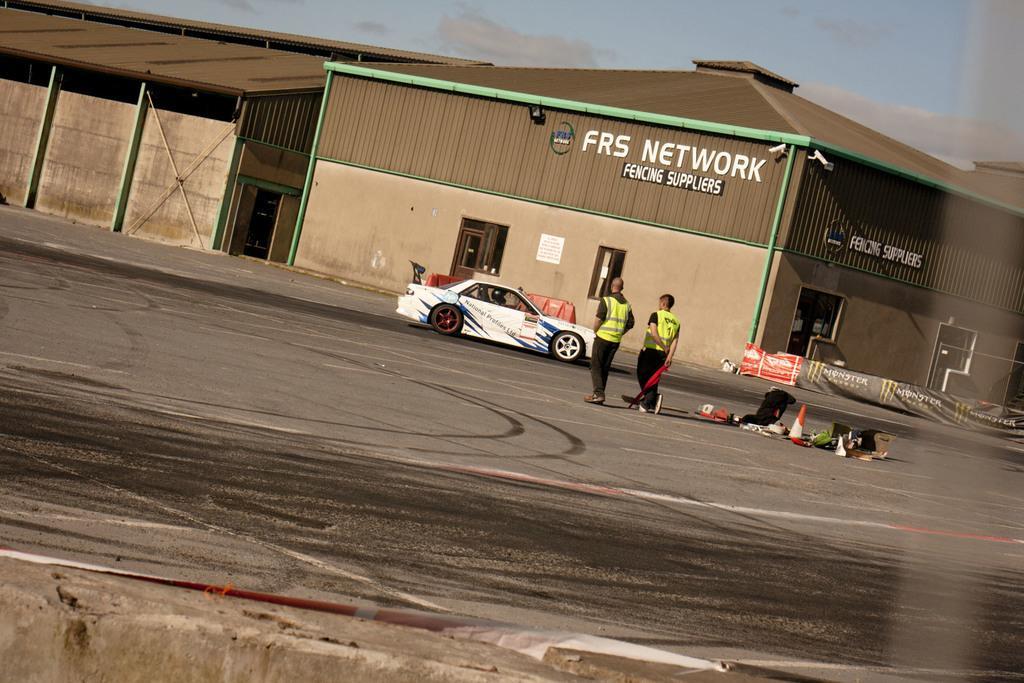Could you give a brief overview of what you see in this image? This is an outside view. In the middle of the image there is a car on the road and there are two persons standing facing towards the back side. On the right side a roadside cone, card boxes and some other objects are placed on the road. In the background there are few sheds and a banner on which there is some text. At the top of the image I can see the sky. 